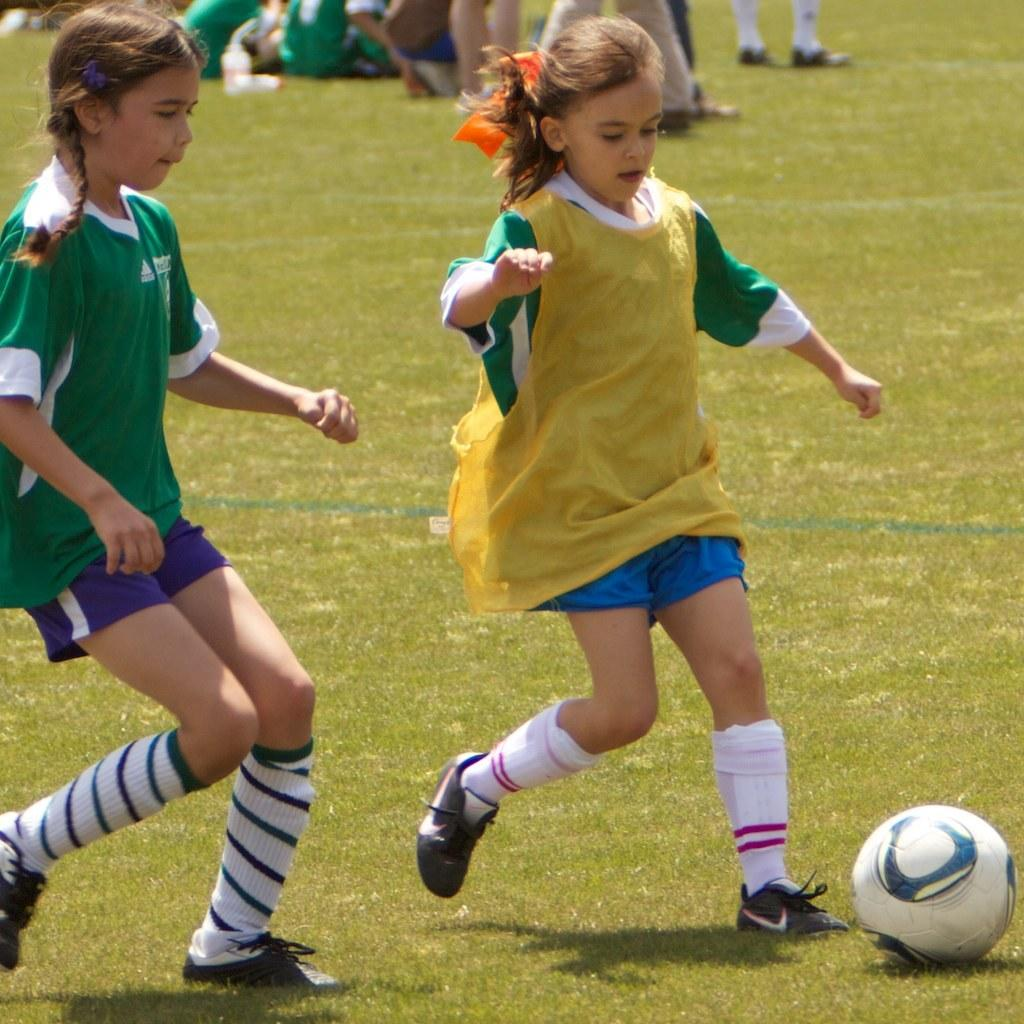How many people are in the image? There are two girls in the image. What activity are the girls engaged in? The girls are playing football. What type of mask is the person wearing in the image? There is no person wearing a mask in the image, as it only features two girls playing football. 